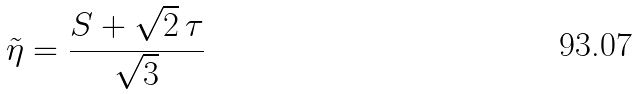Convert formula to latex. <formula><loc_0><loc_0><loc_500><loc_500>\tilde { \eta } = { \frac { S + \sqrt { 2 } \, \tau } { \sqrt { 3 } } }</formula> 